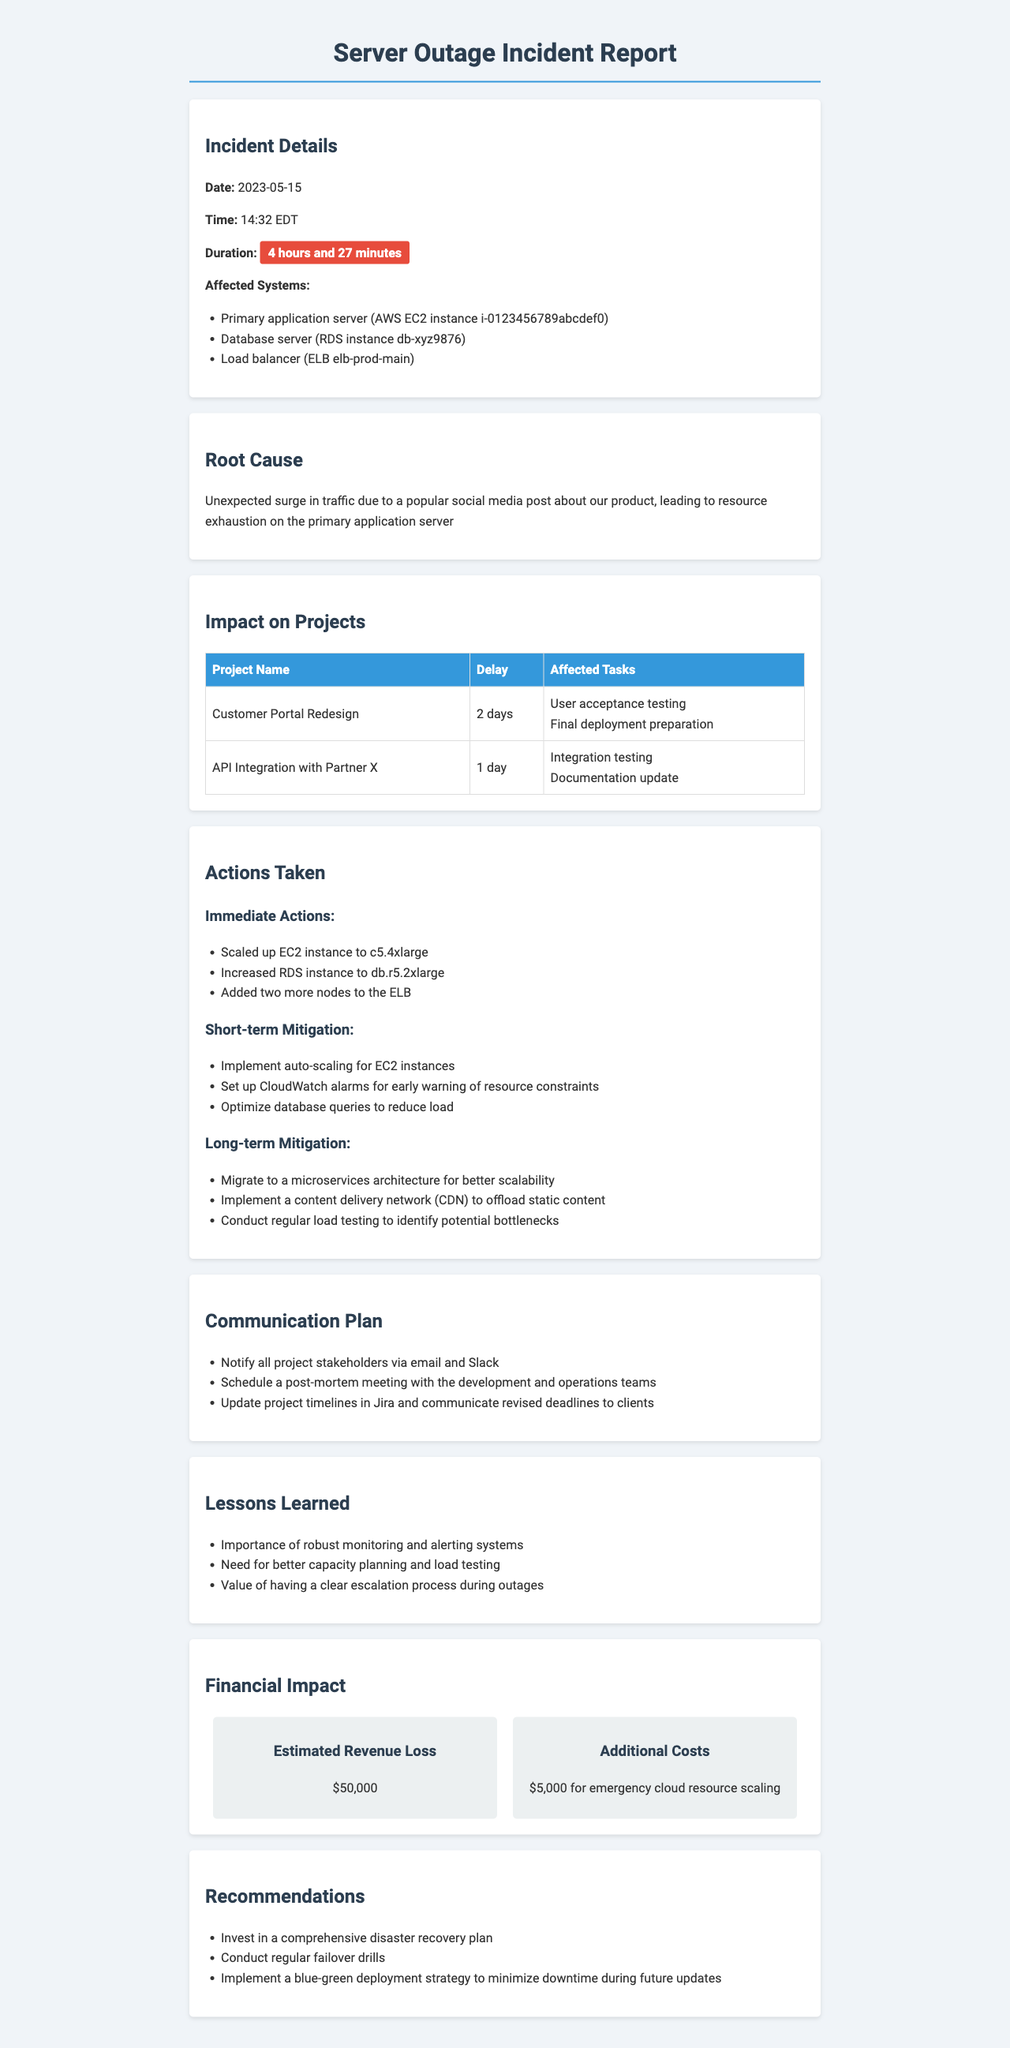what was the date of the incident? The date of the incident is specified in the document.
Answer: 2023-05-15 how long did the outage last? The duration of the outage is mentioned in the document.
Answer: 4 hours and 27 minutes which database server was affected? The affected systems include the database server.
Answer: RDS instance db-xyz9876 what was the estimated revenue loss? The document states the financial impact of the incident.
Answer: $50,000 how many days was the "Customer Portal Redesign" project delayed? The impact on projects lists the delay for this specific project.
Answer: 2 days what immediate action was taken to the EC2 instance? The document mentions the actions taken during the incident.
Answer: Scaled up EC2 instance to c5.4xlarge name one short-term mitigation step proposed. The document lists short-term mitigation steps to prevent future incidents.
Answer: Implement auto-scaling for EC2 instances what lesson was learned regarding monitoring? The lessons learned section provides insights about monitoring.
Answer: Importance of robust monitoring and alerting systems what is one recommendation provided in the report? The recommendations section outlines steps for future improvements.
Answer: Invest in a comprehensive disaster recovery plan 